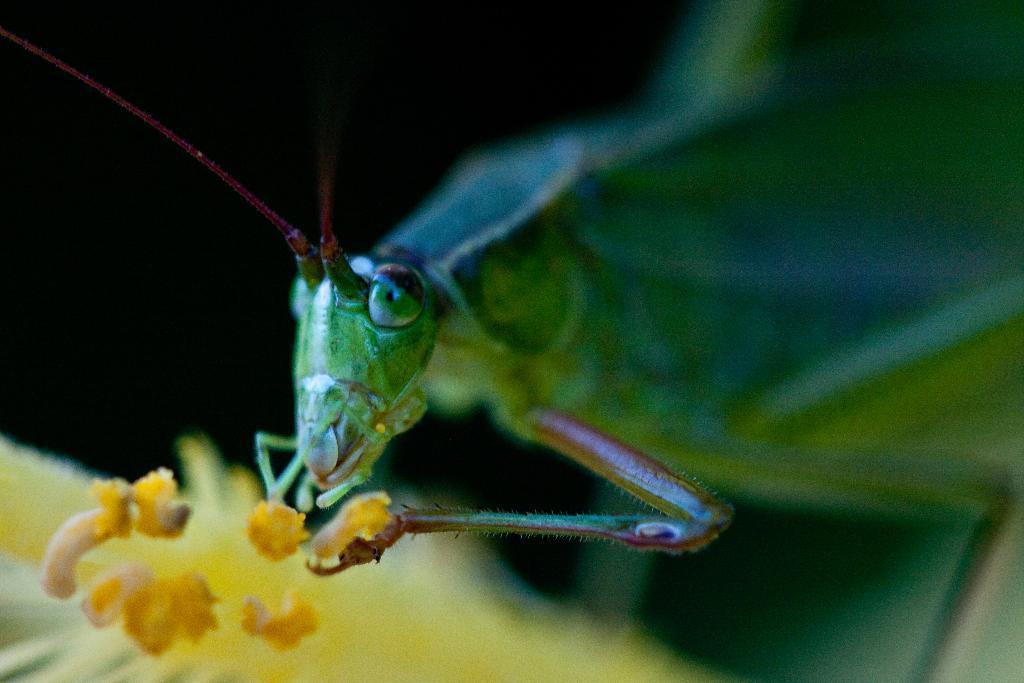How would you summarize this image in a sentence or two? In this image I can see an insect which is green in color on a flower which is yellow in color. I can see the black colored background. 